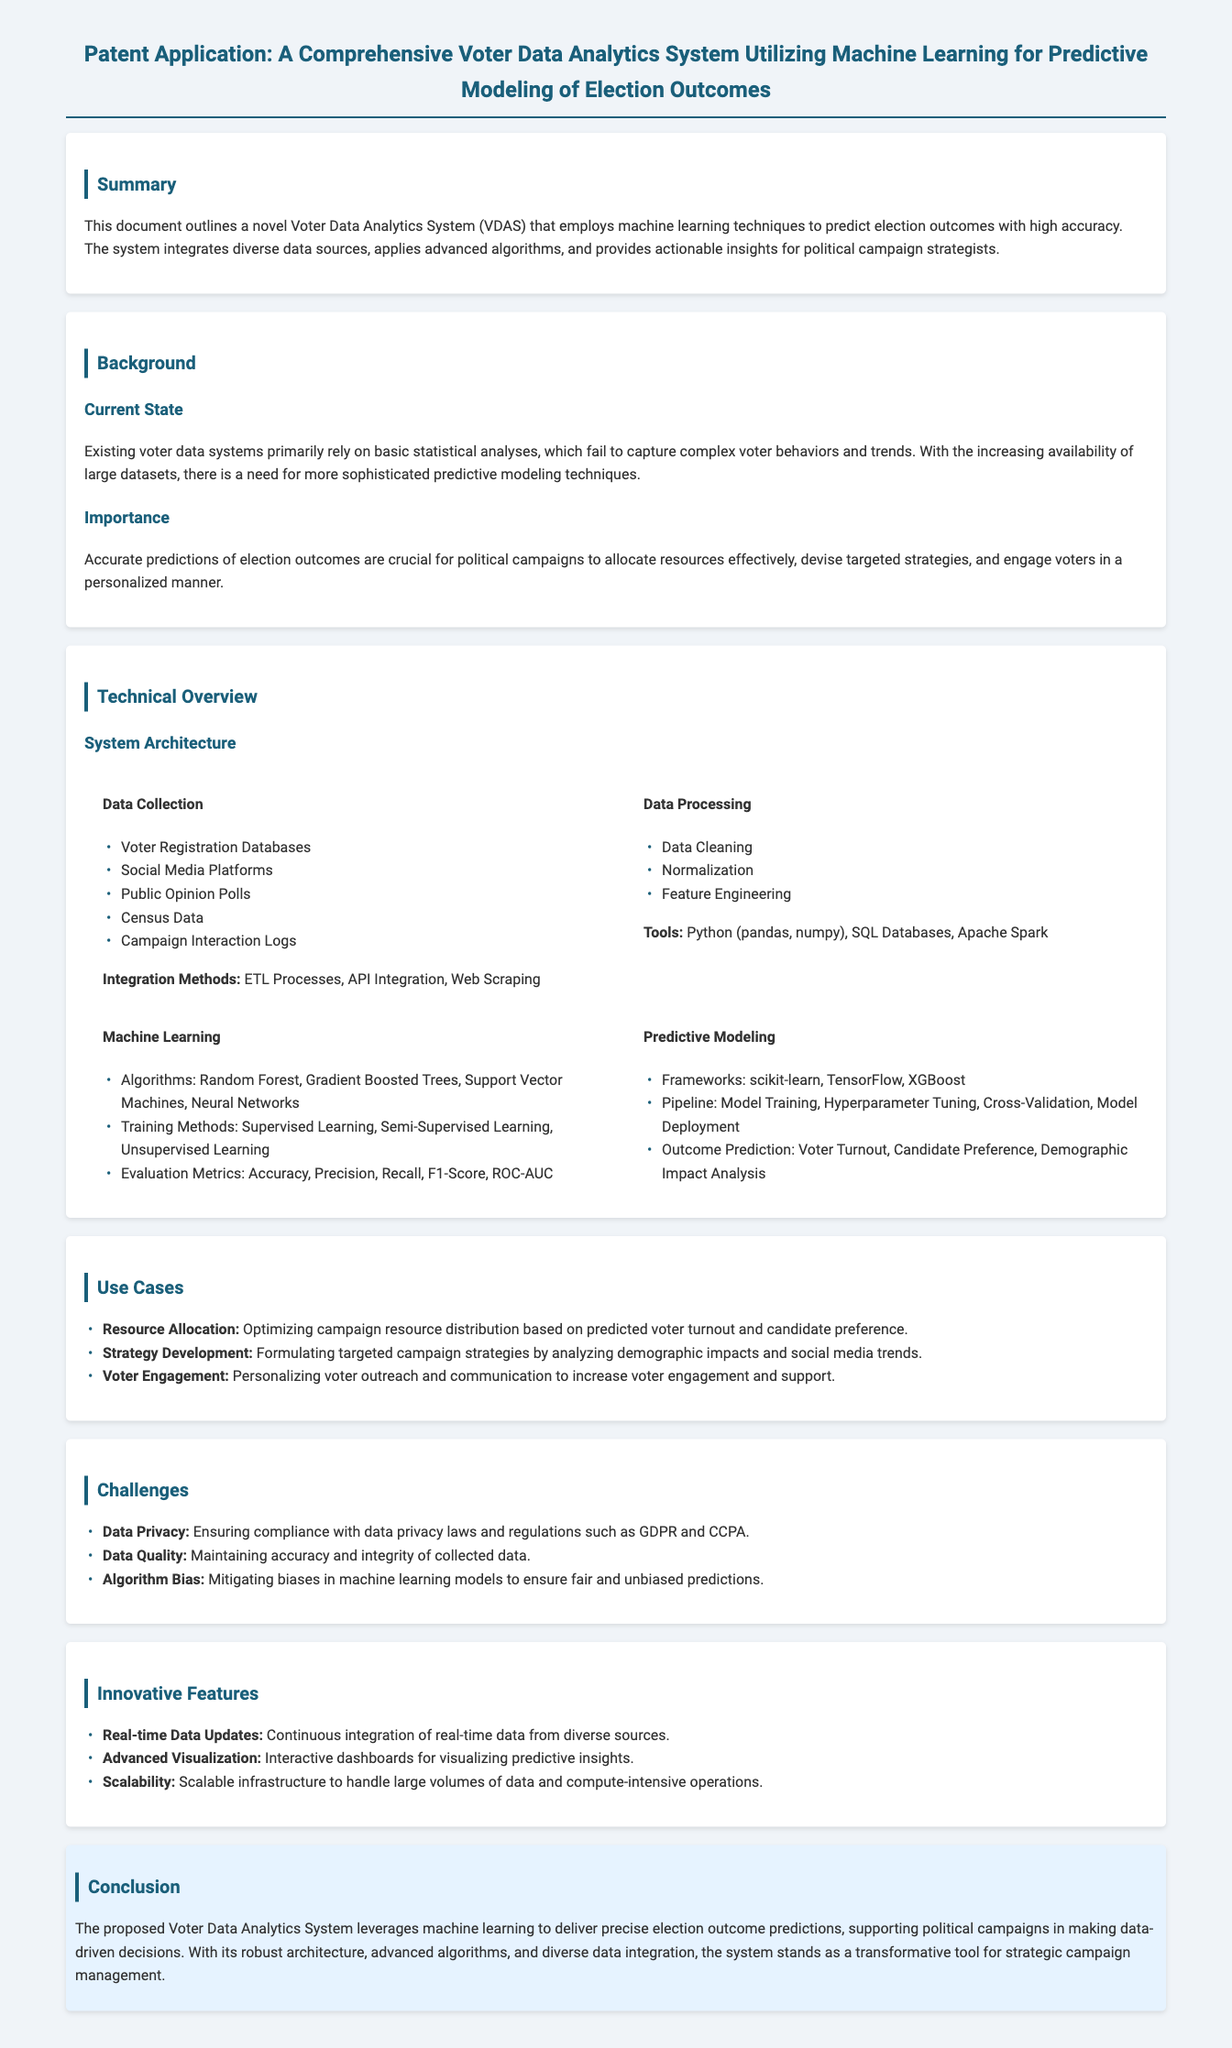What is the title of the patent application? The title is explicitly stated at the beginning of the document.
Answer: A Comprehensive Voter Data Analytics System Utilizing Machine Learning for Predictive Modeling of Election Outcomes What are the integration methods described for data collection? The document lists methods used for integrating collected data.
Answer: ETL Processes, API Integration, Web Scraping What is one of the evaluation metrics used in machine learning? The document outlines several evaluation metrics utilized in the predictive modeling process.
Answer: Accuracy Which algorithm is mentioned as part of the machine learning techniques? The document provides a list of algorithms applied within the system.
Answer: Random Forest What is a use case for the analytics system? The section on use cases details practical applications of the system within political campaigns.
Answer: Resource Allocation What is a challenge highlighted in the document? The challenges section describes difficulties that the system may encounter.
Answer: Data Privacy What is the purpose of the Voter Data Analytics System? The summary outlines the primary goal of the system in the context of election outcomes.
Answer: Predict election outcomes How does the system handle real-time data? The innovative features provide details on the system’s capabilities for data handling.
Answer: Continuous integration of real-time data What does the section on technical overview begin with? The structure of the document is organized with specific sections beginning with key topics.
Answer: System Architecture 